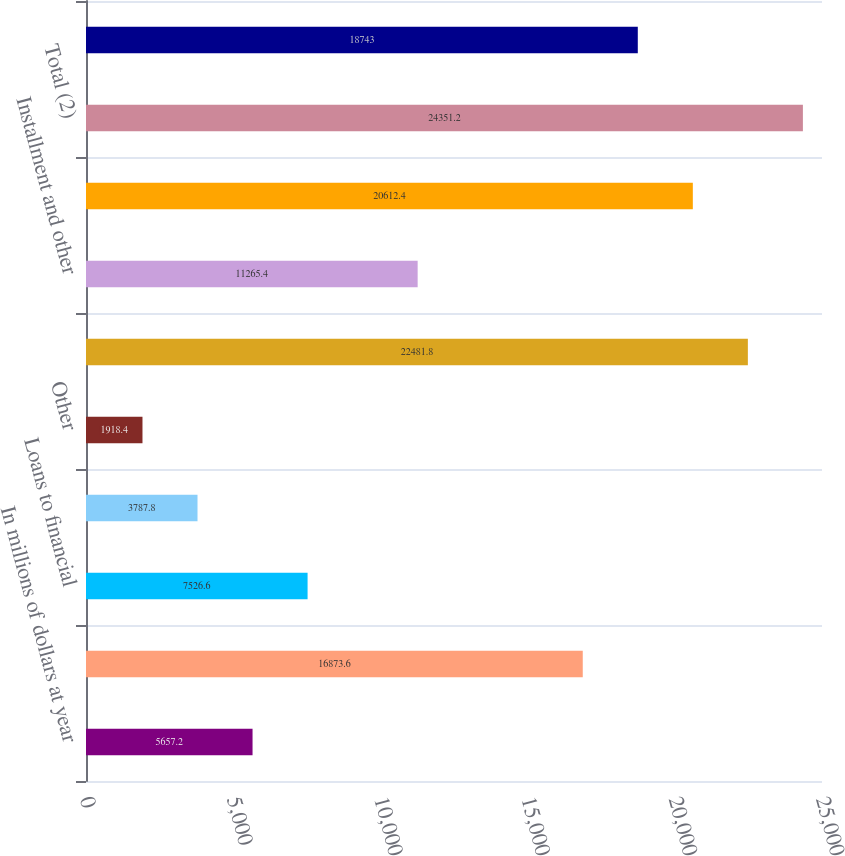Convert chart to OTSL. <chart><loc_0><loc_0><loc_500><loc_500><bar_chart><fcel>In millions of dollars at year<fcel>Commercial and industrial<fcel>Loans to financial<fcel>Mortgage and real estate<fcel>Other<fcel>Total impaired corporate loans<fcel>Installment and other<fcel>Total impaired consumer loans<fcel>Total (2)<fcel>Impaired corporate loans with<nl><fcel>5657.2<fcel>16873.6<fcel>7526.6<fcel>3787.8<fcel>1918.4<fcel>22481.8<fcel>11265.4<fcel>20612.4<fcel>24351.2<fcel>18743<nl></chart> 